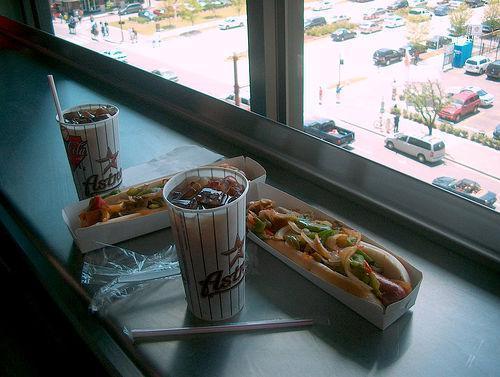How many cups are pictured?
Give a very brief answer. 2. How many hot dogs are shown?
Give a very brief answer. 2. How many hot dogs can be seen?
Give a very brief answer. 2. How many cups are there?
Give a very brief answer. 2. 